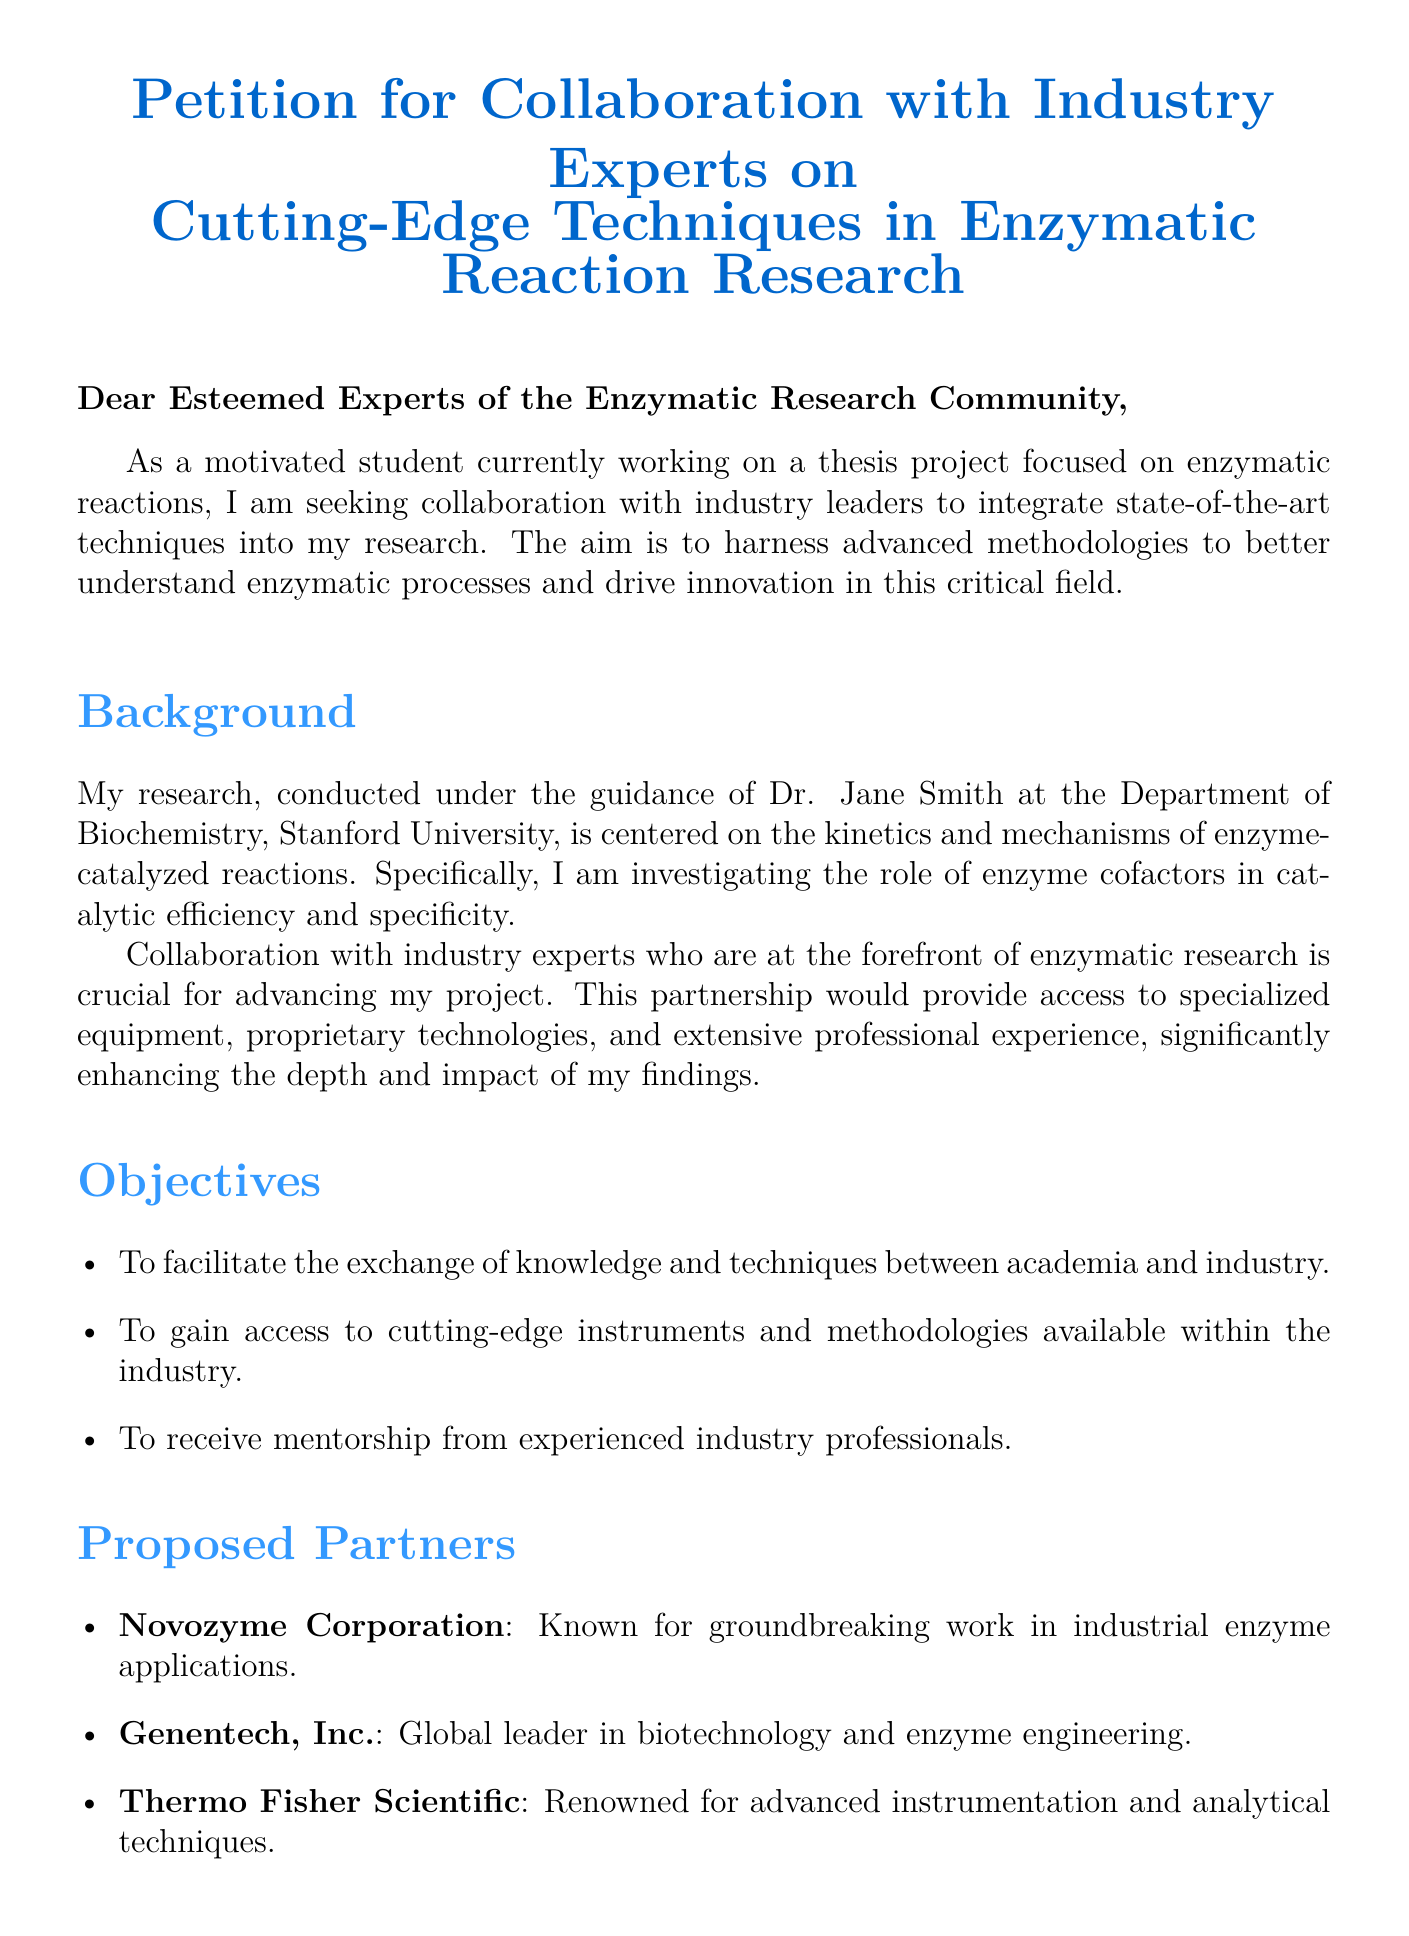What is the title of the document? The title appears at the top of the document and summarizes its purpose.
Answer: Petition for Collaboration with Industry Experts on Cutting-Edge Techniques in Enzymatic Reaction Research Who is the author of the petition? The author is mentioned in the closing section of the document.
Answer: [Your Name] Which university is the research conducted at? The document states the specific institution where the research is being conducted.
Answer: Stanford University What is the primary focus of the research? The main topic of the research is explicitly stated in the document.
Answer: Kinetics and mechanisms of enzyme-catalyzed reactions What are the proposed partners mentioned? The document lists organizations that the author wishes to collaborate with.
Answer: Novozyme Corporation, Genentech, Inc., Thermo Fisher Scientific What is one objective of the collaboration? The objectives are listed in a bullet format, providing clear goals of the endeavor.
Answer: To facilitate the exchange of knowledge and techniques between academia and industry What benefit does the author expect from the collaboration? The benefits are outlined in a section dedicated to the advantages of the partnership.
Answer: Enhanced academic output through integration of advanced technologies What is the name of the advisor mentioned in the petition? The document provides the name of the person guiding the research.
Answer: Dr. Jane Smith What is the main goal of the petition? The purpose of the petition can be summarized by examining the introductory statements.
Answer: To seek collaboration with industry leaders 